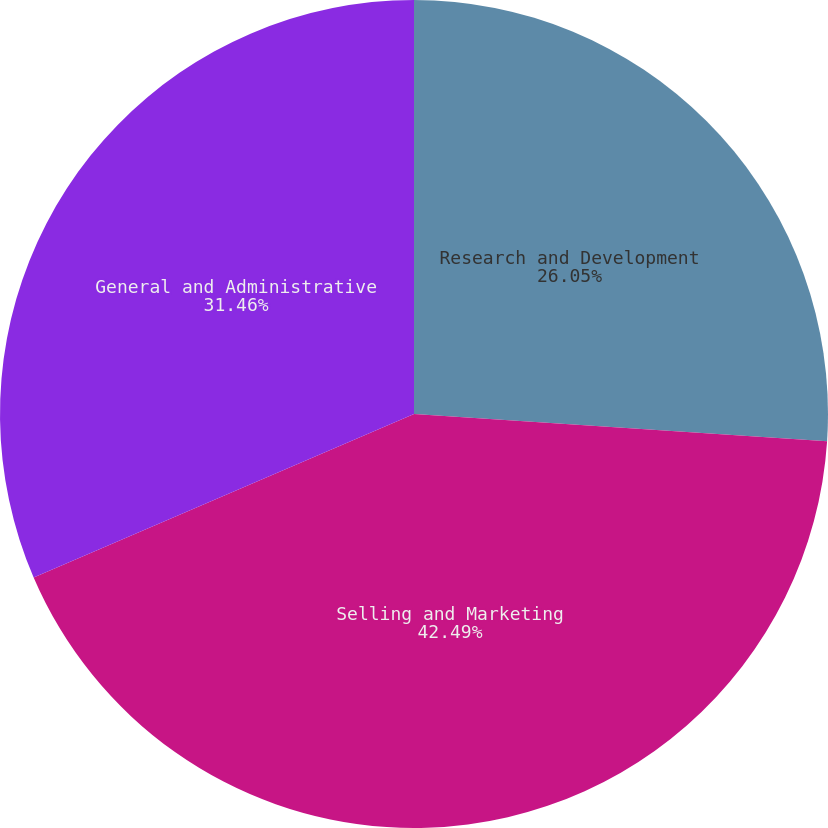Convert chart to OTSL. <chart><loc_0><loc_0><loc_500><loc_500><pie_chart><fcel>Research and Development<fcel>Selling and Marketing<fcel>General and Administrative<nl><fcel>26.05%<fcel>42.49%<fcel>31.46%<nl></chart> 